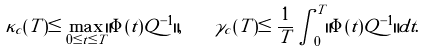<formula> <loc_0><loc_0><loc_500><loc_500>\kappa _ { c } ( T ) \leq \max _ { 0 \leq t \leq T } \| \Phi ( t ) Q ^ { - 1 } \| , \quad \gamma _ { c } ( T ) \leq \frac { 1 } T \int _ { 0 } ^ { T } \| \Phi ( t ) Q ^ { - 1 } \| d t .</formula> 